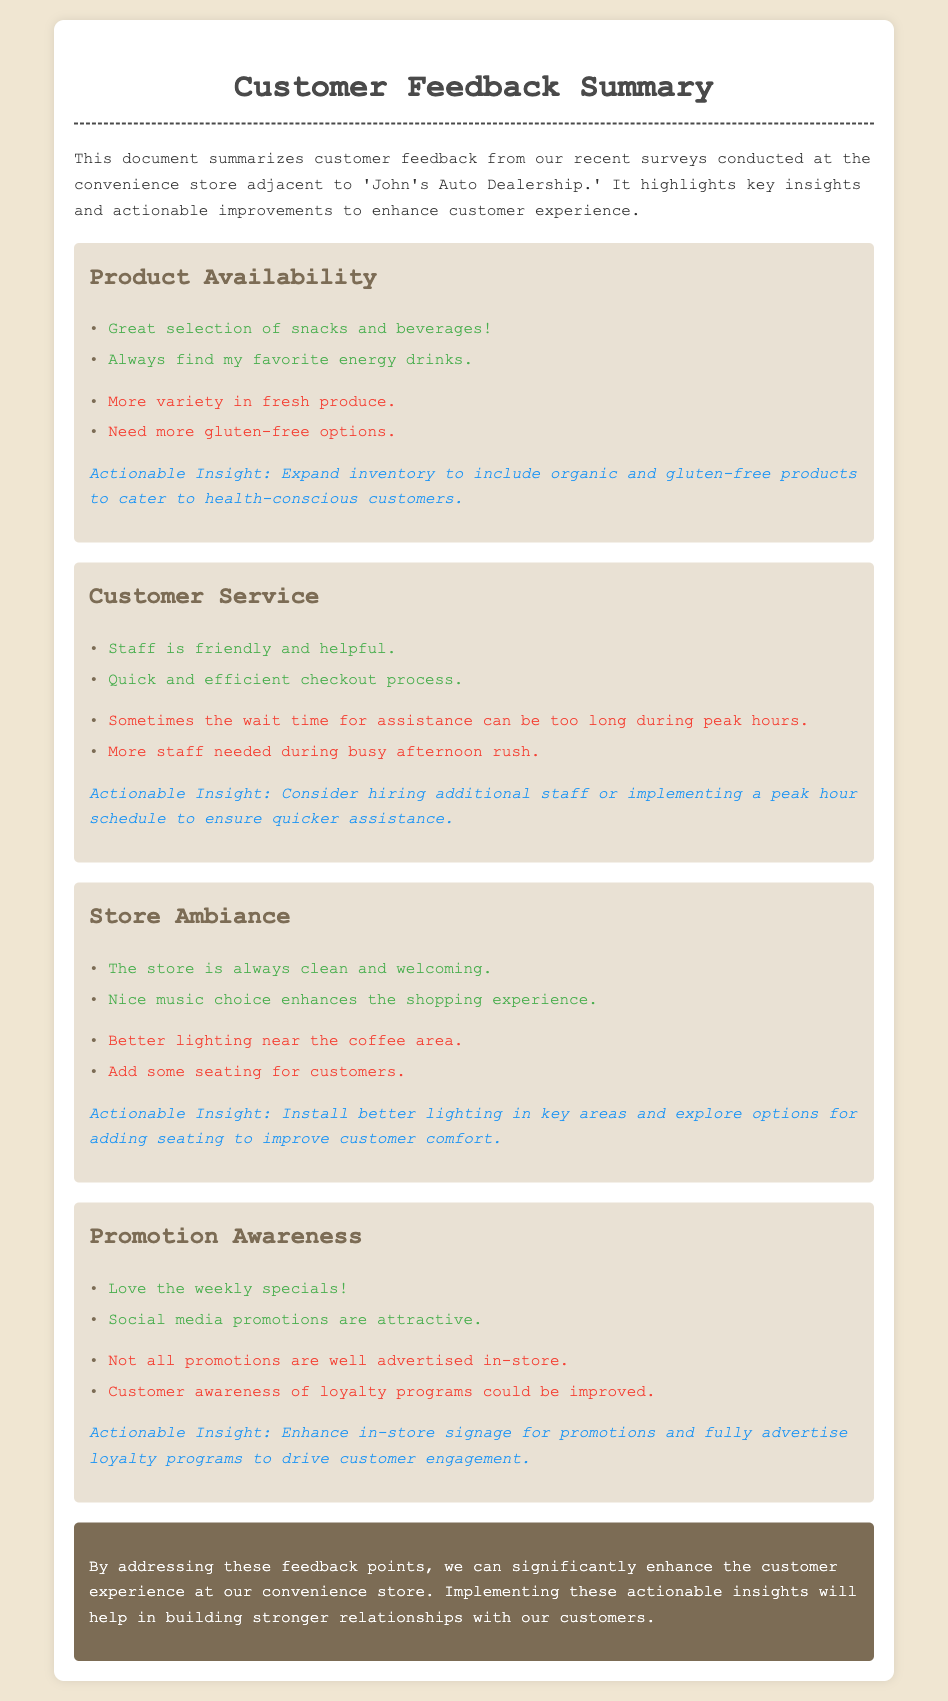What are the key areas of feedback? The document highlights four main areas of customer feedback: Product Availability, Customer Service, Store Ambiance, and Promotion Awareness.
Answer: Four What improvement is suggested for Product Availability? The document states that there needs to be more variety in fresh produce and more gluten-free options.
Answer: More variety in fresh produce and more gluten-free options What actionable insight is provided for Customer Service? The insight suggests considering hiring additional staff or implementing a peak hour schedule for quicker assistance.
Answer: Hire additional staff or implement a peak hour schedule What positive feedback was given about the store's ambiance? Customers mentioned that the store is always clean and welcoming, along with a nice music choice.
Answer: Clean and welcoming How are promotions currently perceived in terms of awareness? Customers indicated that not all promotions are well advertised in-store and there is room for improvement in loyalty program awareness.
Answer: Not well advertised What is one suggested change for the store ambiance? Adding some seating for customers is suggested to improve comfort.
Answer: Add seating What is mentioned about the checkout process? The feedback highlights that the checkout process is quick and efficient.
Answer: Quick and efficient What is one positive aspect of Promotion Awareness? The document notes that customers love the weekly specials.
Answer: Love the weekly specials 